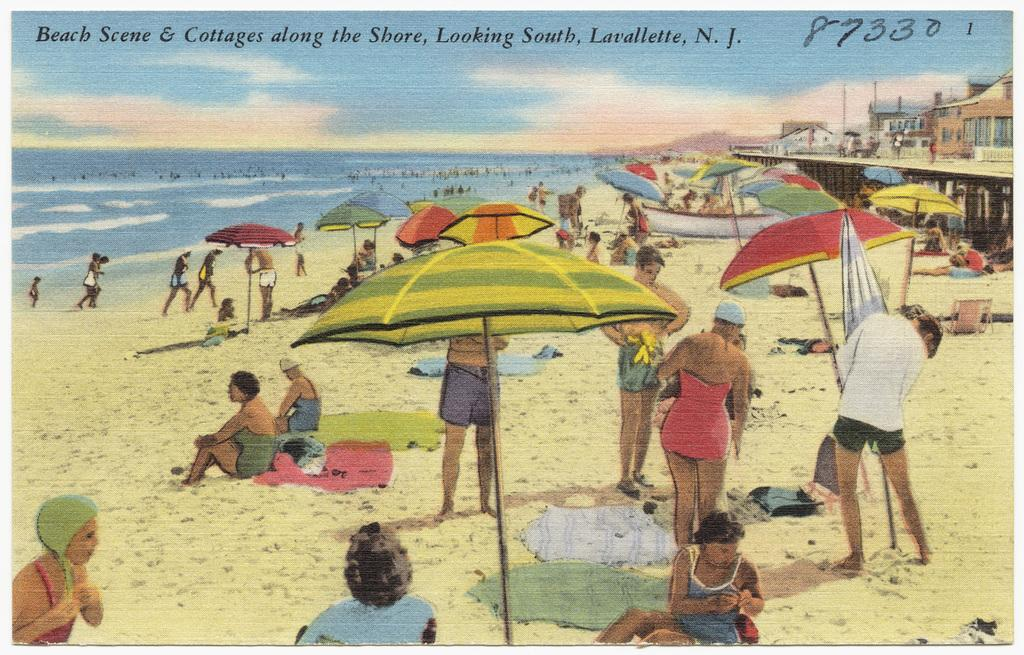What type of image is being described? The image is animated. What is the main setting of the image? There is a beach in the image. How many people are present in the image? There are many people in front of the beach. What are the people doing in the image? The people are doing different activities. What structures can be seen behind the people? There are cottages behind the people. What type of gate can be seen near the cottages in the image? There is no gate visible near the cottages in the image. Can you describe the trail that the girl is walking on in the image? There is no girl or trail present in the image. 